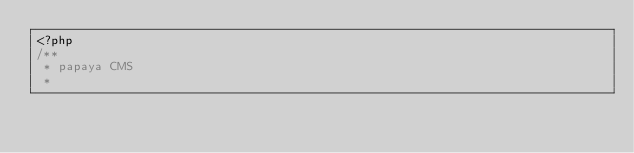Convert code to text. <code><loc_0><loc_0><loc_500><loc_500><_PHP_><?php
/**
 * papaya CMS
 *</code> 